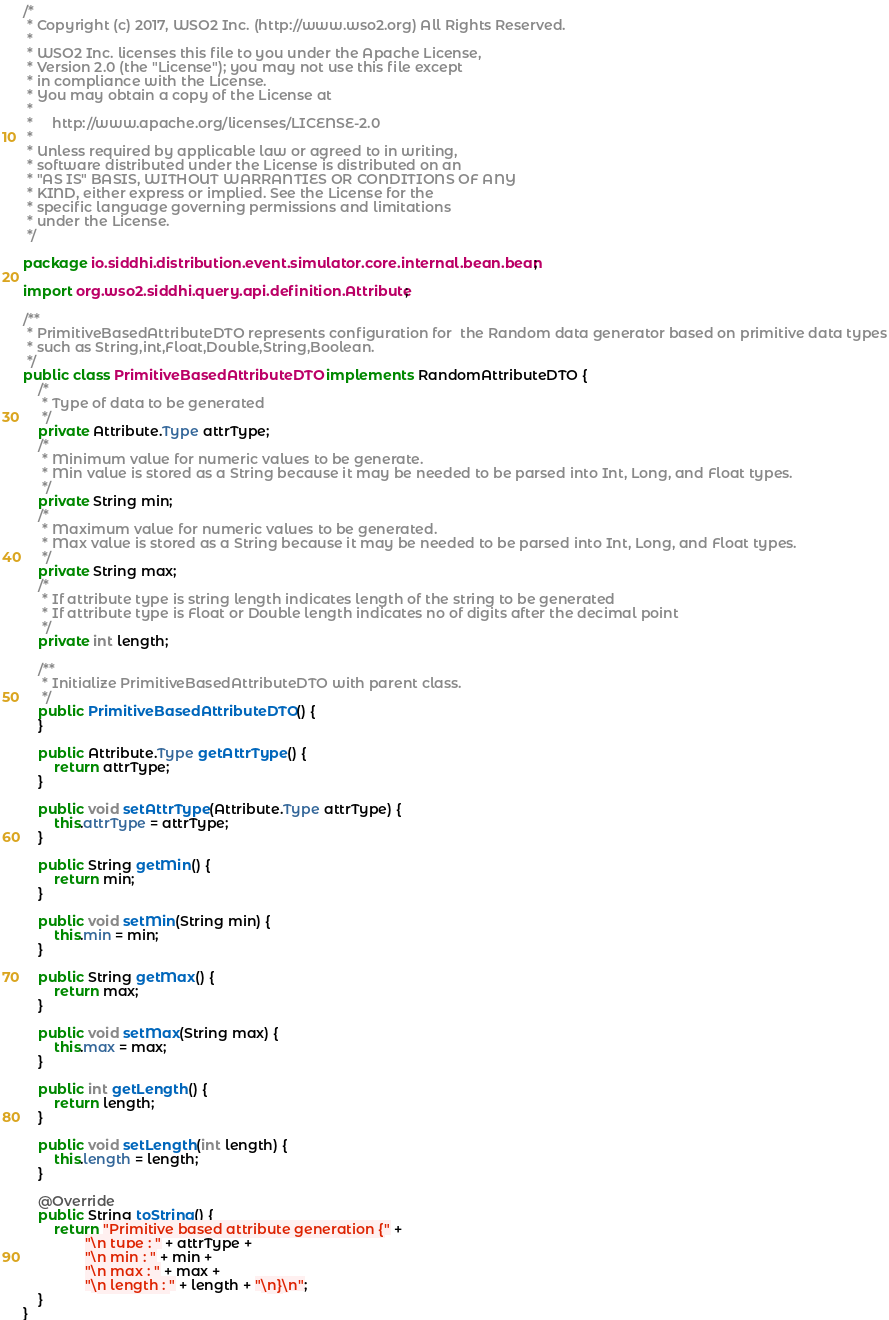Convert code to text. <code><loc_0><loc_0><loc_500><loc_500><_Java_>/*
 * Copyright (c) 2017, WSO2 Inc. (http://www.wso2.org) All Rights Reserved.
 *
 * WSO2 Inc. licenses this file to you under the Apache License,
 * Version 2.0 (the "License"); you may not use this file except
 * in compliance with the License.
 * You may obtain a copy of the License at
 *
 *     http://www.apache.org/licenses/LICENSE-2.0
 *
 * Unless required by applicable law or agreed to in writing,
 * software distributed under the License is distributed on an
 * "AS IS" BASIS, WITHOUT WARRANTIES OR CONDITIONS OF ANY
 * KIND, either express or implied. See the License for the
 * specific language governing permissions and limitations
 * under the License.
 */

package io.siddhi.distribution.event.simulator.core.internal.bean.bean;

import org.wso2.siddhi.query.api.definition.Attribute;

/**
 * PrimitiveBasedAttributeDTO represents configuration for  the Random data generator based on primitive data types
 * such as String,int,Float,Double,String,Boolean.
 */
public class PrimitiveBasedAttributeDTO implements RandomAttributeDTO {
    /*
     * Type of data to be generated
     */
    private Attribute.Type attrType;
    /*
     * Minimum value for numeric values to be generate.
     * Min value is stored as a String because it may be needed to be parsed into Int, Long, and Float types.
     */
    private String min;
    /*
     * Maximum value for numeric values to be generated.
     * Max value is stored as a String because it may be needed to be parsed into Int, Long, and Float types.
     */
    private String max;
    /*
     * If attribute type is string length indicates length of the string to be generated
     * If attribute type is Float or Double length indicates no of digits after the decimal point
     */
    private int length;

    /**
     * Initialize PrimitiveBasedAttributeDTO with parent class.
     */
    public PrimitiveBasedAttributeDTO() {
    }

    public Attribute.Type getAttrType() {
        return attrType;
    }

    public void setAttrType(Attribute.Type attrType) {
        this.attrType = attrType;
    }

    public String getMin() {
        return min;
    }

    public void setMin(String min) {
        this.min = min;
    }

    public String getMax() {
        return max;
    }

    public void setMax(String max) {
        this.max = max;
    }

    public int getLength() {
        return length;
    }

    public void setLength(int length) {
        this.length = length;
    }

    @Override
    public String toString() {
        return "Primitive based attribute generation {" +
                "\n type : " + attrType +
                "\n min : " + min +
                "\n max : " + max +
                "\n length : " + length + "\n}\n";
    }
}
</code> 